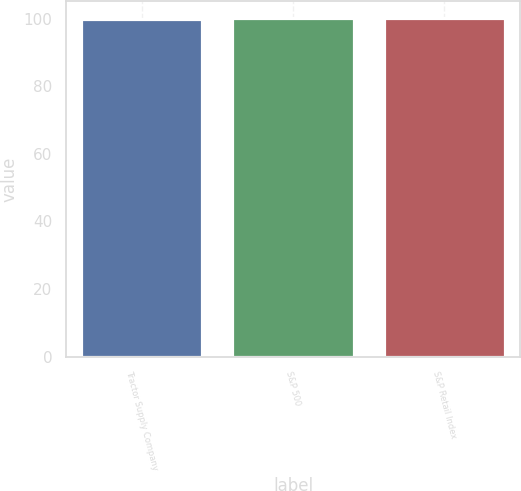Convert chart. <chart><loc_0><loc_0><loc_500><loc_500><bar_chart><fcel>Tractor Supply Company<fcel>S&P 500<fcel>S&P Retail Index<nl><fcel>100<fcel>100.1<fcel>100.2<nl></chart> 